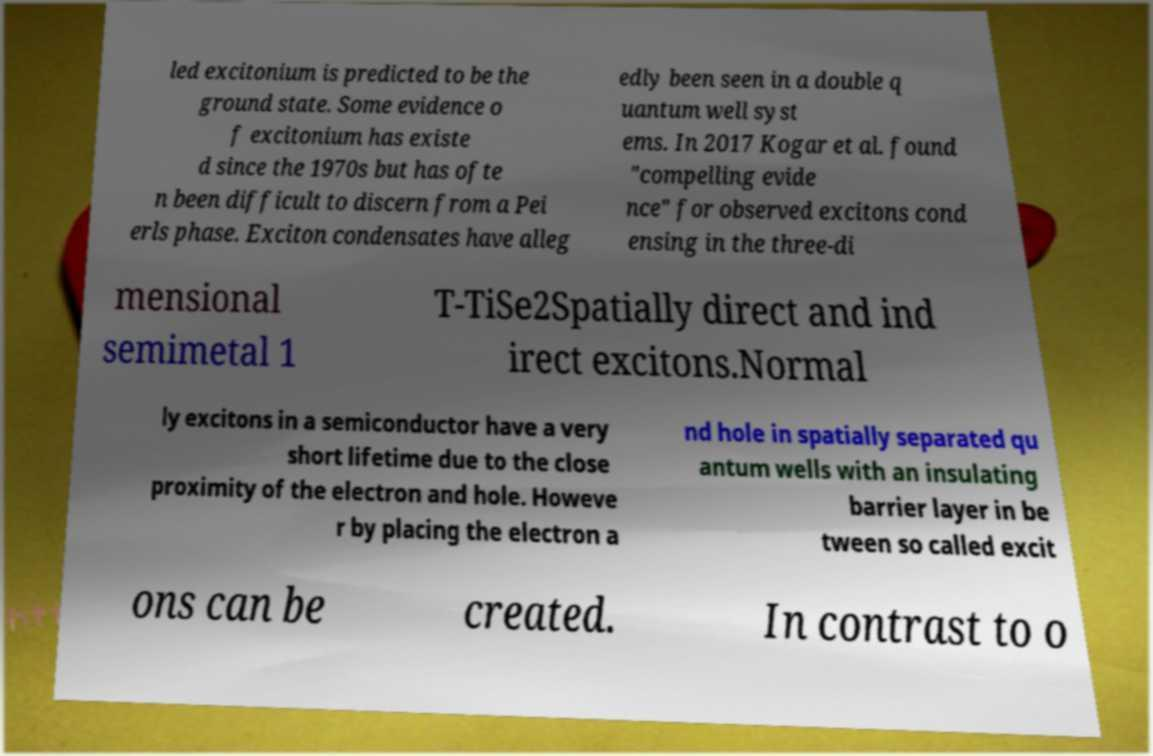Could you extract and type out the text from this image? led excitonium is predicted to be the ground state. Some evidence o f excitonium has existe d since the 1970s but has ofte n been difficult to discern from a Pei erls phase. Exciton condensates have alleg edly been seen in a double q uantum well syst ems. In 2017 Kogar et al. found "compelling evide nce" for observed excitons cond ensing in the three-di mensional semimetal 1 T-TiSe2Spatially direct and ind irect excitons.Normal ly excitons in a semiconductor have a very short lifetime due to the close proximity of the electron and hole. Howeve r by placing the electron a nd hole in spatially separated qu antum wells with an insulating barrier layer in be tween so called excit ons can be created. In contrast to o 